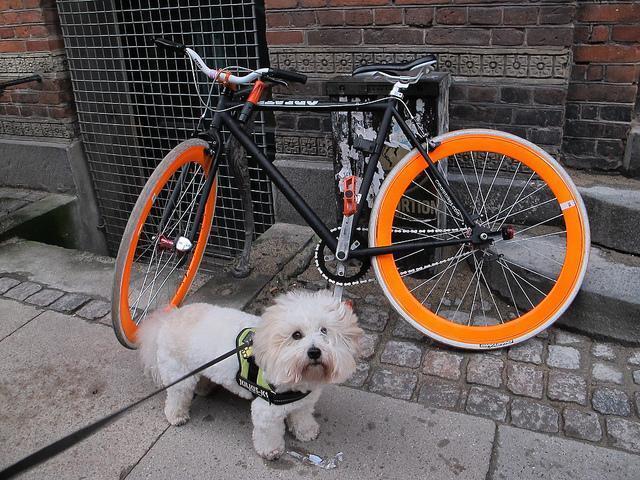How many dogs are in the picture?
Give a very brief answer. 1. 